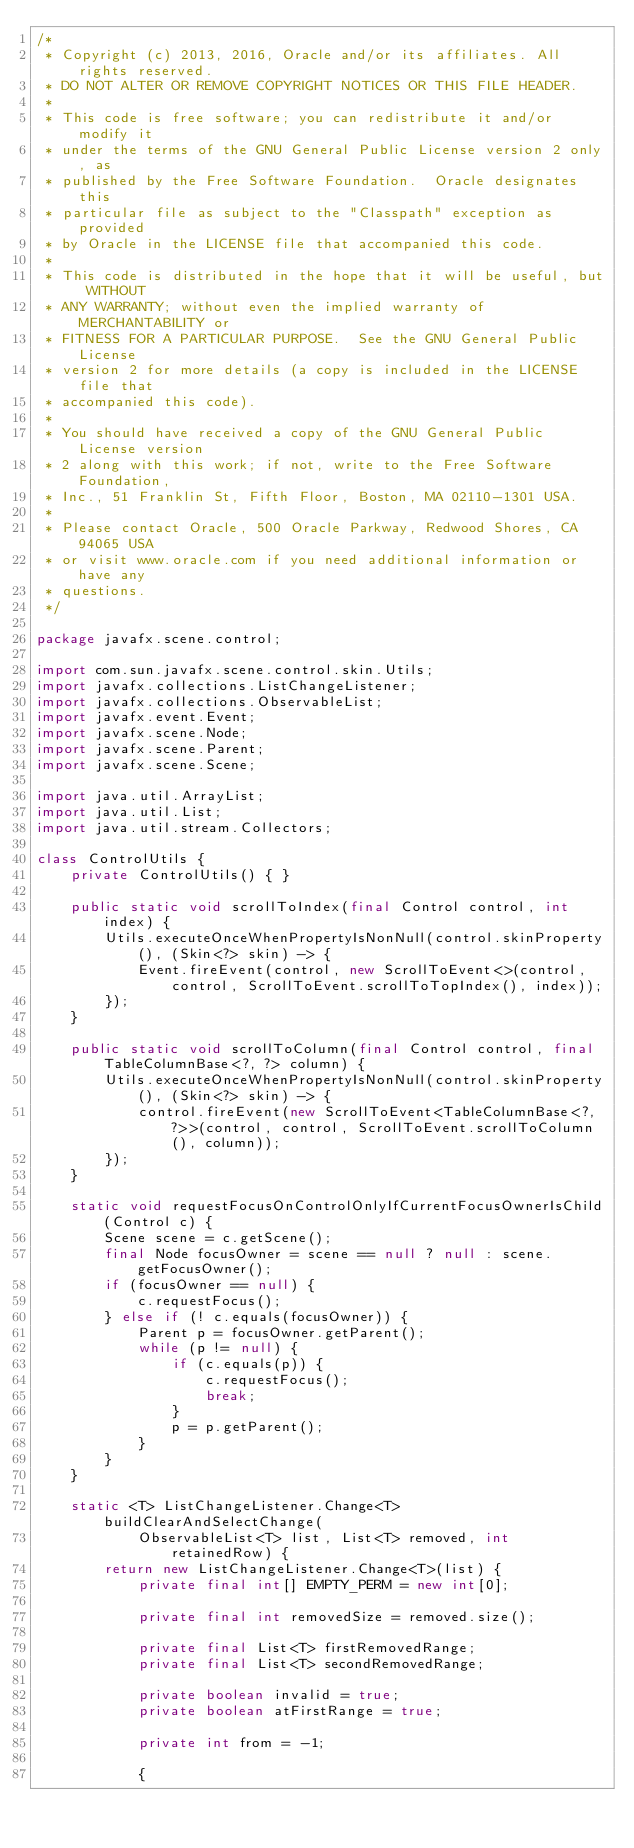Convert code to text. <code><loc_0><loc_0><loc_500><loc_500><_Java_>/*
 * Copyright (c) 2013, 2016, Oracle and/or its affiliates. All rights reserved.
 * DO NOT ALTER OR REMOVE COPYRIGHT NOTICES OR THIS FILE HEADER.
 *
 * This code is free software; you can redistribute it and/or modify it
 * under the terms of the GNU General Public License version 2 only, as
 * published by the Free Software Foundation.  Oracle designates this
 * particular file as subject to the "Classpath" exception as provided
 * by Oracle in the LICENSE file that accompanied this code.
 *
 * This code is distributed in the hope that it will be useful, but WITHOUT
 * ANY WARRANTY; without even the implied warranty of MERCHANTABILITY or
 * FITNESS FOR A PARTICULAR PURPOSE.  See the GNU General Public License
 * version 2 for more details (a copy is included in the LICENSE file that
 * accompanied this code).
 *
 * You should have received a copy of the GNU General Public License version
 * 2 along with this work; if not, write to the Free Software Foundation,
 * Inc., 51 Franklin St, Fifth Floor, Boston, MA 02110-1301 USA.
 *
 * Please contact Oracle, 500 Oracle Parkway, Redwood Shores, CA 94065 USA
 * or visit www.oracle.com if you need additional information or have any
 * questions.
 */

package javafx.scene.control;

import com.sun.javafx.scene.control.skin.Utils;
import javafx.collections.ListChangeListener;
import javafx.collections.ObservableList;
import javafx.event.Event;
import javafx.scene.Node;
import javafx.scene.Parent;
import javafx.scene.Scene;

import java.util.ArrayList;
import java.util.List;
import java.util.stream.Collectors;

class ControlUtils {
    private ControlUtils() { }

    public static void scrollToIndex(final Control control, int index) {
        Utils.executeOnceWhenPropertyIsNonNull(control.skinProperty(), (Skin<?> skin) -> {
            Event.fireEvent(control, new ScrollToEvent<>(control, control, ScrollToEvent.scrollToTopIndex(), index));
        });
    }

    public static void scrollToColumn(final Control control, final TableColumnBase<?, ?> column) {
        Utils.executeOnceWhenPropertyIsNonNull(control.skinProperty(), (Skin<?> skin) -> {
            control.fireEvent(new ScrollToEvent<TableColumnBase<?, ?>>(control, control, ScrollToEvent.scrollToColumn(), column));
        });
    }

    static void requestFocusOnControlOnlyIfCurrentFocusOwnerIsChild(Control c) {
        Scene scene = c.getScene();
        final Node focusOwner = scene == null ? null : scene.getFocusOwner();
        if (focusOwner == null) {
            c.requestFocus();
        } else if (! c.equals(focusOwner)) {
            Parent p = focusOwner.getParent();
            while (p != null) {
                if (c.equals(p)) {
                    c.requestFocus();
                    break;
                }
                p = p.getParent();
            }
        }
    }

    static <T> ListChangeListener.Change<T> buildClearAndSelectChange(
            ObservableList<T> list, List<T> removed, int retainedRow) {
        return new ListChangeListener.Change<T>(list) {
            private final int[] EMPTY_PERM = new int[0];

            private final int removedSize = removed.size();

            private final List<T> firstRemovedRange;
            private final List<T> secondRemovedRange;

            private boolean invalid = true;
            private boolean atFirstRange = true;

            private int from = -1;

            {</code> 